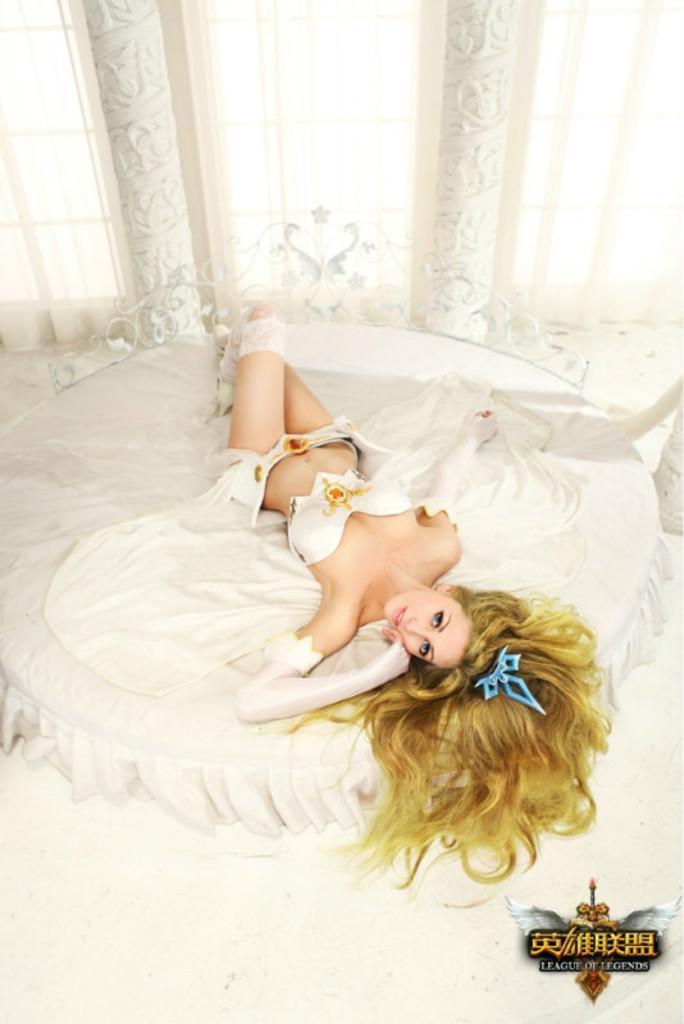In one or two sentences, can you explain what this image depicts? This image consists of a woman sleeping on a bed. She is wearing a white dress. At the bottom, there is a floor. In the background, we can see the windows along with the curtains in white color. 